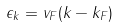<formula> <loc_0><loc_0><loc_500><loc_500>\epsilon _ { k } = v _ { F } ( k - k _ { F } )</formula> 